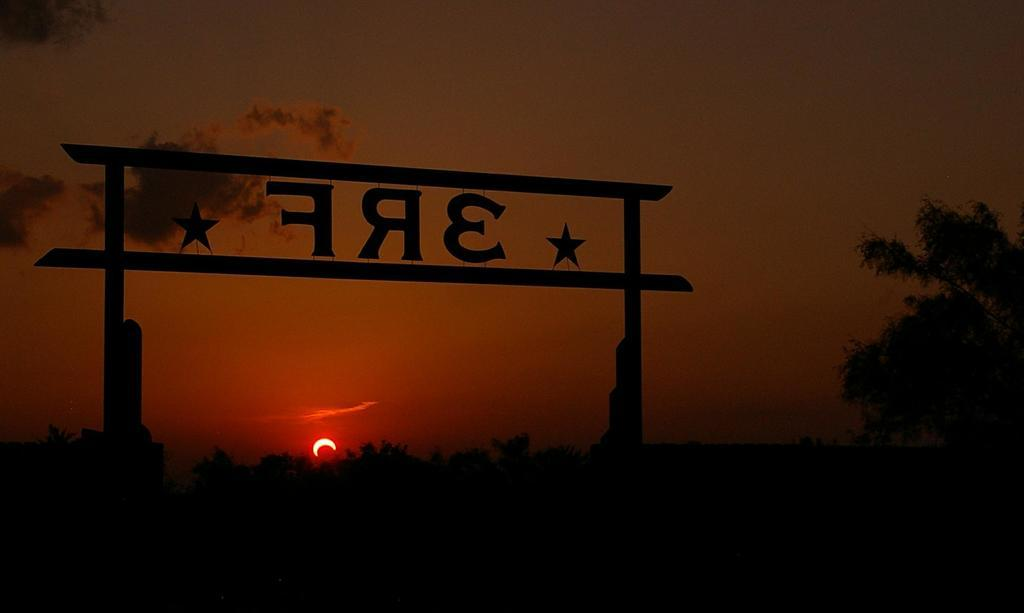What structure is present in the image with text on it? There is an arch with text in the image. What type of vegetation can be seen in the image? There are plants and trees in the image. What celestial body is visible in the image? The sun is visible in the image. What is the condition of the sky in the image? The sky is cloudy in the image. How many pigs are climbing the arch in the image? There are no pigs present in the image, so it is not possible to determine how many might be climbing the arch. 